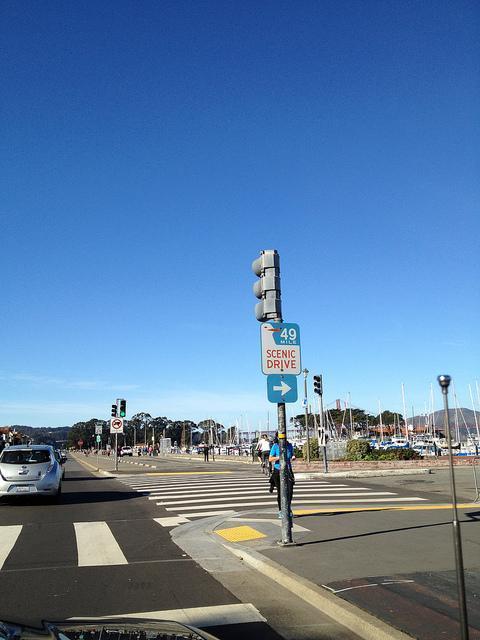How many ways do the arrows point?
Give a very brief answer. 1. 